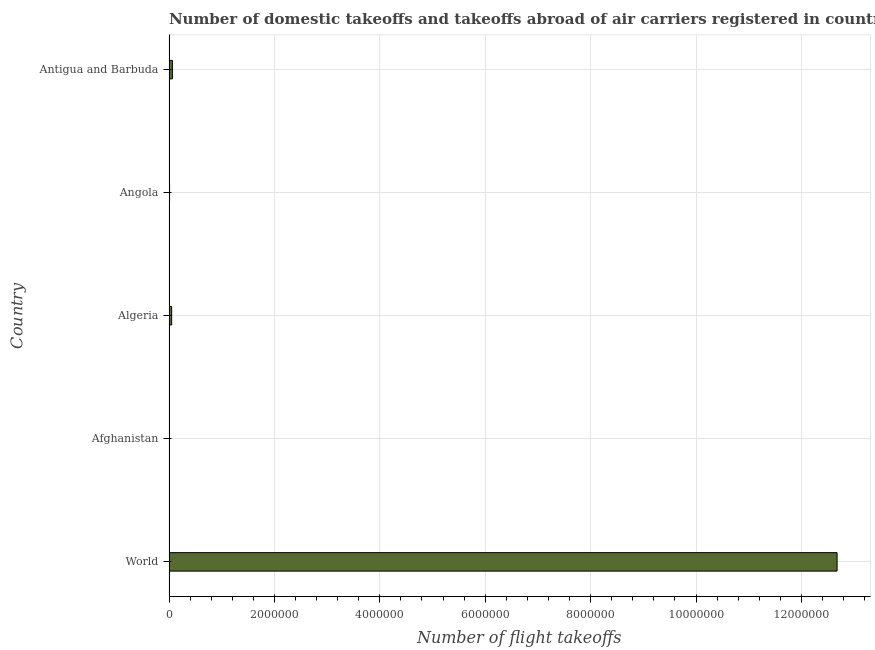Does the graph contain any zero values?
Give a very brief answer. No. Does the graph contain grids?
Provide a short and direct response. Yes. What is the title of the graph?
Keep it short and to the point. Number of domestic takeoffs and takeoffs abroad of air carriers registered in countries. What is the label or title of the X-axis?
Provide a short and direct response. Number of flight takeoffs. What is the number of flight takeoffs in Algeria?
Your response must be concise. 5.05e+04. Across all countries, what is the maximum number of flight takeoffs?
Keep it short and to the point. 1.27e+07. Across all countries, what is the minimum number of flight takeoffs?
Your answer should be very brief. 5800. In which country was the number of flight takeoffs minimum?
Your response must be concise. Afghanistan. What is the sum of the number of flight takeoffs?
Provide a succinct answer. 1.28e+07. What is the difference between the number of flight takeoffs in Angola and World?
Your answer should be very brief. -1.27e+07. What is the average number of flight takeoffs per country?
Provide a short and direct response. 2.56e+06. What is the median number of flight takeoffs?
Make the answer very short. 5.05e+04. What is the ratio of the number of flight takeoffs in Algeria to that in World?
Your response must be concise. 0. Is the number of flight takeoffs in Antigua and Barbuda less than that in World?
Make the answer very short. Yes. Is the difference between the number of flight takeoffs in Antigua and Barbuda and World greater than the difference between any two countries?
Make the answer very short. No. What is the difference between the highest and the second highest number of flight takeoffs?
Ensure brevity in your answer.  1.26e+07. What is the difference between the highest and the lowest number of flight takeoffs?
Your response must be concise. 1.27e+07. How many countries are there in the graph?
Make the answer very short. 5. Are the values on the major ticks of X-axis written in scientific E-notation?
Your answer should be very brief. No. What is the Number of flight takeoffs of World?
Ensure brevity in your answer.  1.27e+07. What is the Number of flight takeoffs of Afghanistan?
Offer a very short reply. 5800. What is the Number of flight takeoffs in Algeria?
Keep it short and to the point. 5.05e+04. What is the Number of flight takeoffs of Angola?
Offer a very short reply. 1.11e+04. What is the Number of flight takeoffs in Antigua and Barbuda?
Your response must be concise. 6.50e+04. What is the difference between the Number of flight takeoffs in World and Afghanistan?
Keep it short and to the point. 1.27e+07. What is the difference between the Number of flight takeoffs in World and Algeria?
Offer a very short reply. 1.26e+07. What is the difference between the Number of flight takeoffs in World and Angola?
Your response must be concise. 1.27e+07. What is the difference between the Number of flight takeoffs in World and Antigua and Barbuda?
Provide a short and direct response. 1.26e+07. What is the difference between the Number of flight takeoffs in Afghanistan and Algeria?
Offer a very short reply. -4.47e+04. What is the difference between the Number of flight takeoffs in Afghanistan and Angola?
Make the answer very short. -5300. What is the difference between the Number of flight takeoffs in Afghanistan and Antigua and Barbuda?
Your answer should be very brief. -5.92e+04. What is the difference between the Number of flight takeoffs in Algeria and Angola?
Offer a very short reply. 3.94e+04. What is the difference between the Number of flight takeoffs in Algeria and Antigua and Barbuda?
Keep it short and to the point. -1.45e+04. What is the difference between the Number of flight takeoffs in Angola and Antigua and Barbuda?
Provide a succinct answer. -5.39e+04. What is the ratio of the Number of flight takeoffs in World to that in Afghanistan?
Your response must be concise. 2185.69. What is the ratio of the Number of flight takeoffs in World to that in Algeria?
Your response must be concise. 251.03. What is the ratio of the Number of flight takeoffs in World to that in Angola?
Give a very brief answer. 1142.07. What is the ratio of the Number of flight takeoffs in World to that in Antigua and Barbuda?
Offer a terse response. 195.03. What is the ratio of the Number of flight takeoffs in Afghanistan to that in Algeria?
Give a very brief answer. 0.12. What is the ratio of the Number of flight takeoffs in Afghanistan to that in Angola?
Your answer should be compact. 0.52. What is the ratio of the Number of flight takeoffs in Afghanistan to that in Antigua and Barbuda?
Your answer should be very brief. 0.09. What is the ratio of the Number of flight takeoffs in Algeria to that in Angola?
Ensure brevity in your answer.  4.55. What is the ratio of the Number of flight takeoffs in Algeria to that in Antigua and Barbuda?
Your answer should be very brief. 0.78. What is the ratio of the Number of flight takeoffs in Angola to that in Antigua and Barbuda?
Provide a short and direct response. 0.17. 